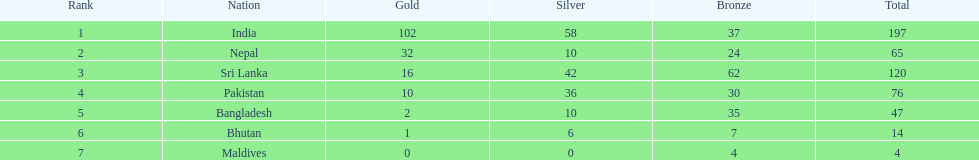In what nation have no silver medals been won? Maldives. 